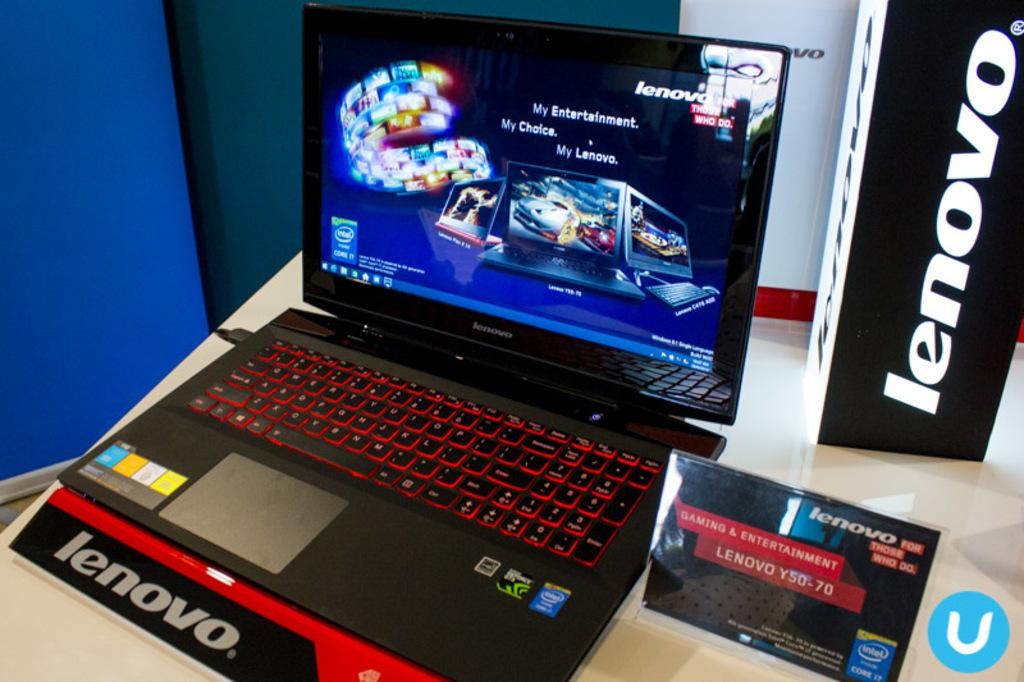Provide a one-sentence caption for the provided image. A laptop with Lenovo markings near it and a game on the screen. 